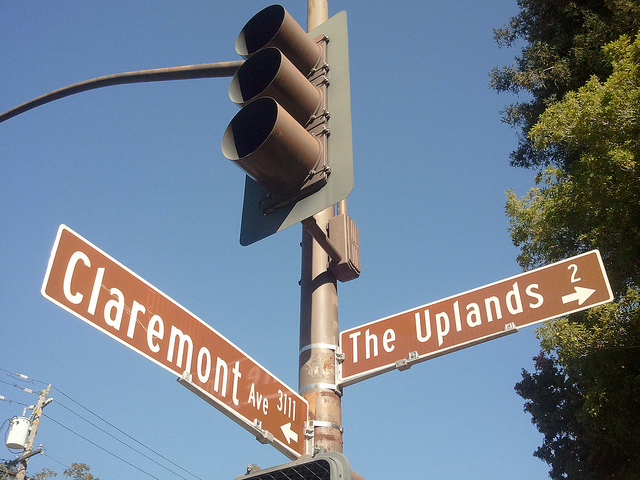<image>Does the stoplight say to go or stop? It is unclear if the stoplight says to go or stop. Does the stoplight say to go or stop? I don't know if the stoplight says to go or stop. It is unclear from the given information. 